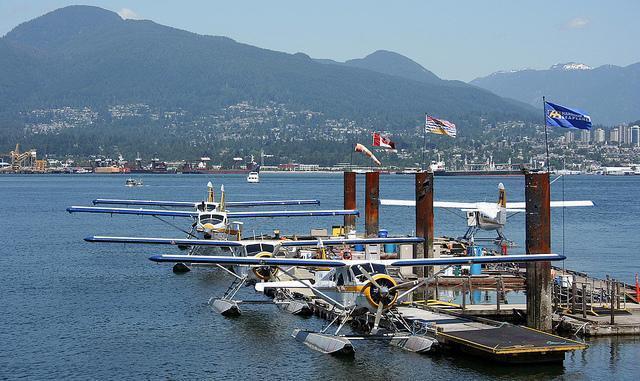How many airplanes are in the water?
Give a very brief answer. 5. How many aircraft wings are there?
Give a very brief answer. 10. How many airplanes are there?
Give a very brief answer. 4. 